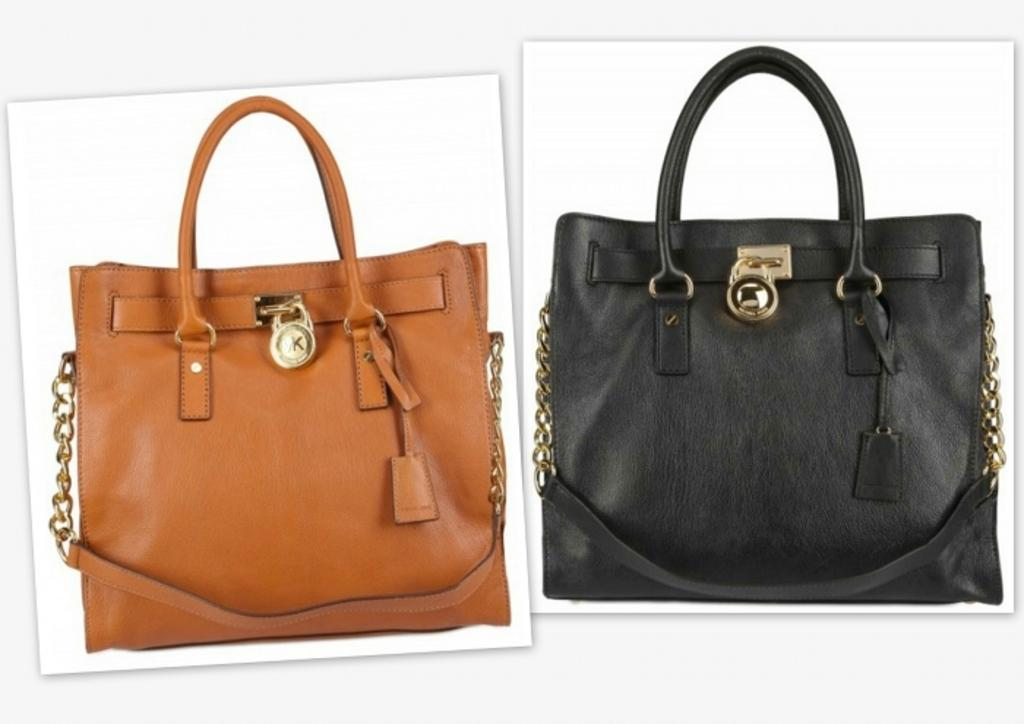How many handbags are visible in the image? There are two handbags in the image. What distinguishes the handbags from each other? The handbags are of different colors. What type of insect can be seen crawling on the handbags in the image? There is no insect present on the handbags in the image. What type of grain is used to make the handbags in the image? The handbags are not made of grain; they are likely made of fabric or leather. 